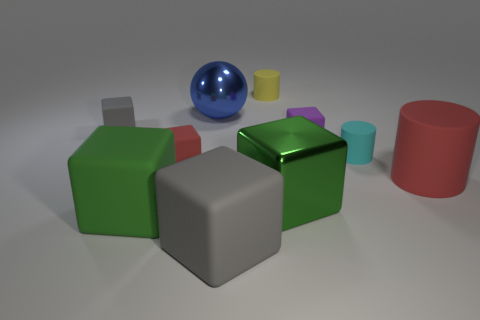There is a red thing that is to the left of the yellow matte cylinder; is it the same shape as the gray thing behind the big green shiny thing?
Make the answer very short. Yes. There is a large sphere; are there any blue things behind it?
Make the answer very short. No. What is the color of the other metal object that is the same shape as the large gray object?
Keep it short and to the point. Green. Are there any other things that are the same shape as the tiny red thing?
Provide a succinct answer. Yes. What material is the purple object on the right side of the small yellow rubber object?
Offer a very short reply. Rubber. What is the size of the shiny object that is the same shape as the green matte thing?
Provide a succinct answer. Large. What number of other small blue balls are made of the same material as the blue sphere?
Offer a very short reply. 0. What number of matte cubes have the same color as the big rubber cylinder?
Give a very brief answer. 1. What number of objects are red matte things left of the metal sphere or things that are behind the green rubber thing?
Offer a terse response. 8. Is the number of tiny gray cubes that are in front of the big blue metal sphere less than the number of small red things?
Offer a terse response. No. 